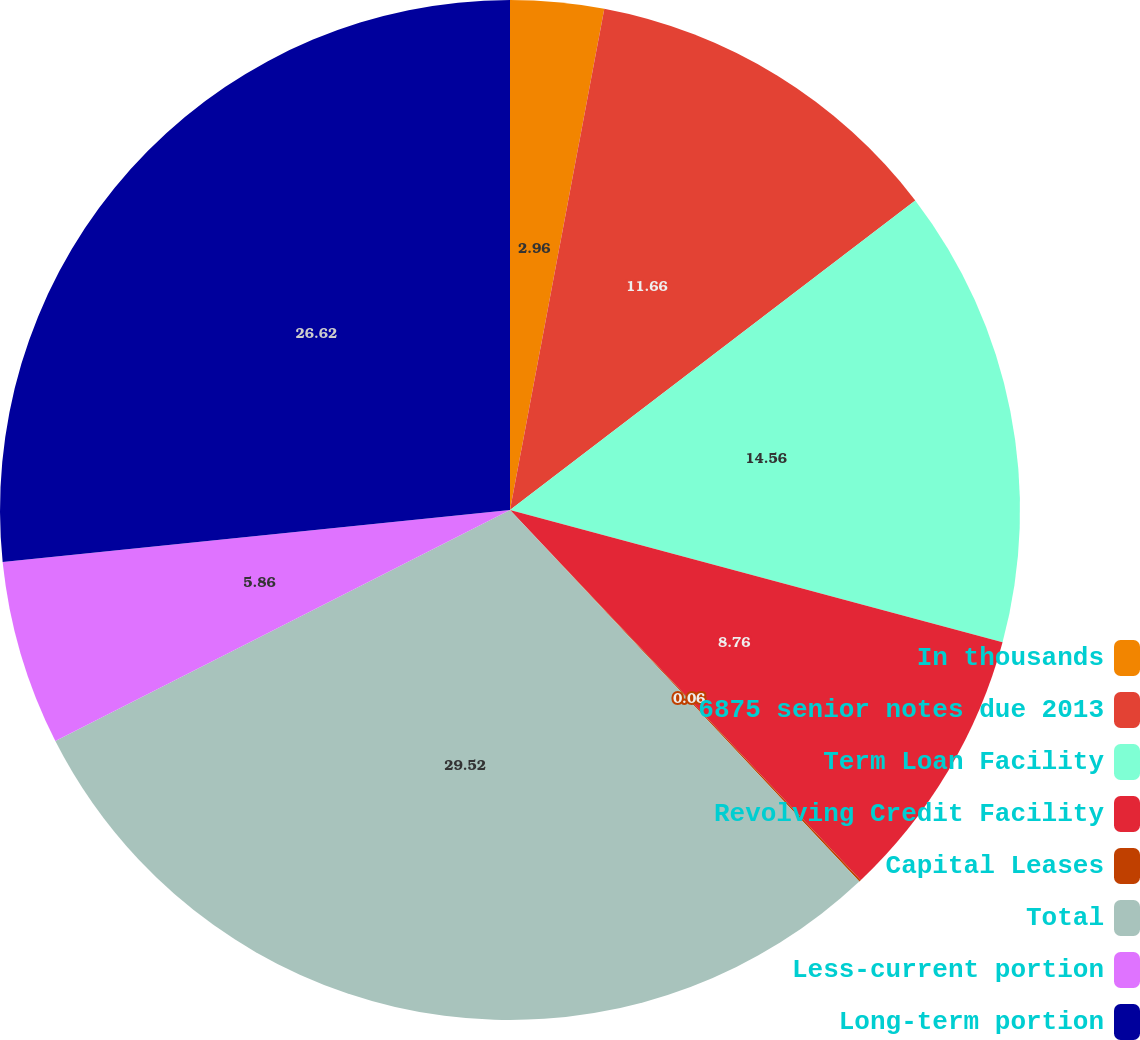<chart> <loc_0><loc_0><loc_500><loc_500><pie_chart><fcel>In thousands<fcel>6875 senior notes due 2013<fcel>Term Loan Facility<fcel>Revolving Credit Facility<fcel>Capital Leases<fcel>Total<fcel>Less-current portion<fcel>Long-term portion<nl><fcel>2.96%<fcel>11.66%<fcel>14.56%<fcel>8.76%<fcel>0.06%<fcel>29.53%<fcel>5.86%<fcel>26.63%<nl></chart> 